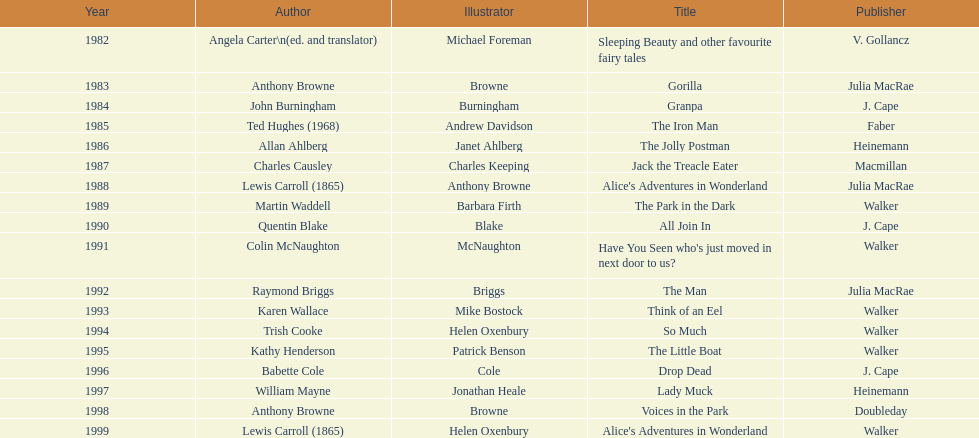How many number of titles are listed for the year 1991? 1. 